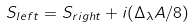<formula> <loc_0><loc_0><loc_500><loc_500>S _ { l e f t } = S _ { r i g h t } + i ( \Delta _ { \lambda } A / 8 )</formula> 